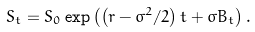<formula> <loc_0><loc_0><loc_500><loc_500>S _ { t } = S _ { 0 } \exp \left ( \left ( r - \sigma ^ { 2 } / 2 \right ) t + \sigma B _ { t } \right ) .</formula> 